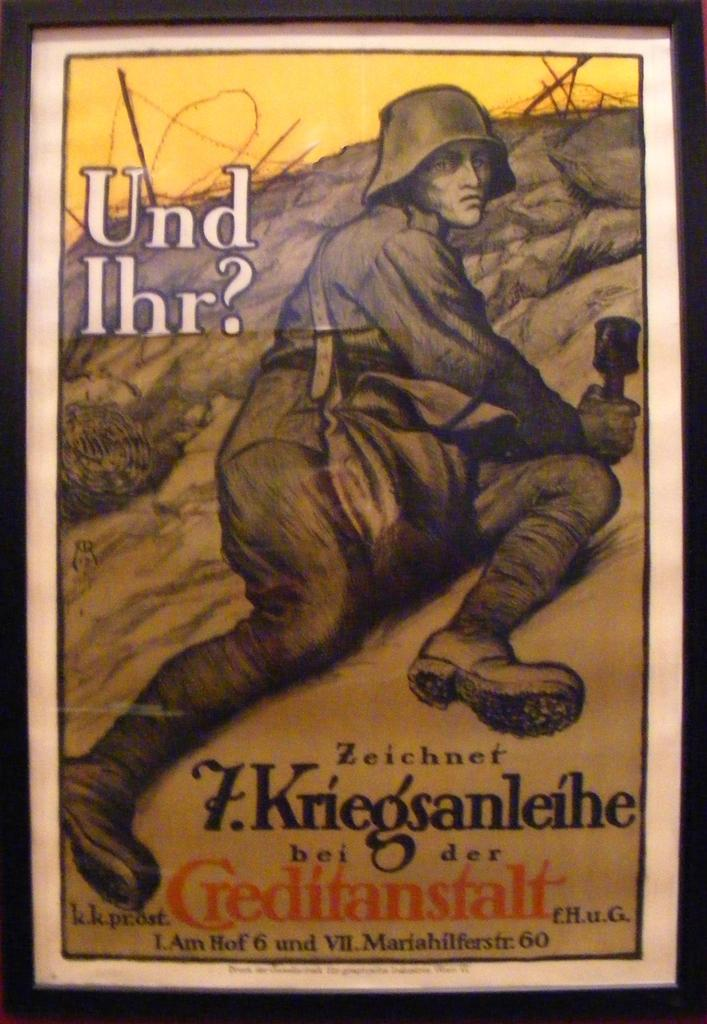<image>
Offer a succinct explanation of the picture presented. a poster with a man on it that says 'und ihr?' 